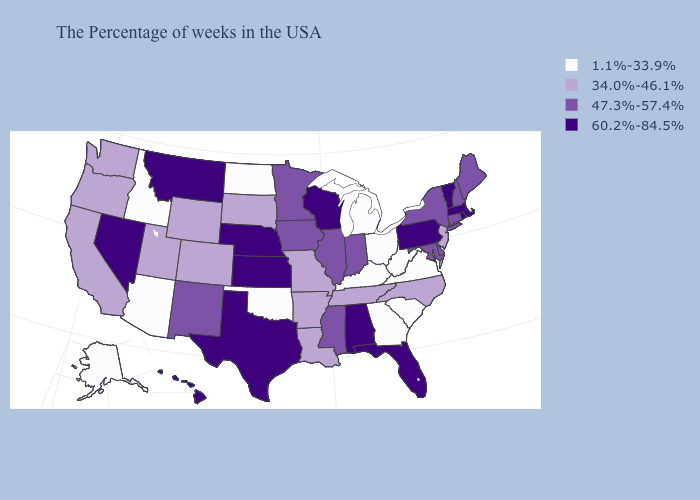How many symbols are there in the legend?
Short answer required. 4. Among the states that border Wyoming , which have the highest value?
Short answer required. Nebraska, Montana. Which states have the lowest value in the Northeast?
Give a very brief answer. New Jersey. What is the highest value in the USA?
Answer briefly. 60.2%-84.5%. What is the lowest value in the West?
Quick response, please. 1.1%-33.9%. What is the value of New Hampshire?
Keep it brief. 47.3%-57.4%. Does the first symbol in the legend represent the smallest category?
Quick response, please. Yes. Name the states that have a value in the range 34.0%-46.1%?
Be succinct. New Jersey, North Carolina, Tennessee, Louisiana, Missouri, Arkansas, South Dakota, Wyoming, Colorado, Utah, California, Washington, Oregon. Name the states that have a value in the range 1.1%-33.9%?
Be succinct. Virginia, South Carolina, West Virginia, Ohio, Georgia, Michigan, Kentucky, Oklahoma, North Dakota, Arizona, Idaho, Alaska. Among the states that border Delaware , which have the highest value?
Short answer required. Pennsylvania. Does Illinois have a lower value than Alabama?
Short answer required. Yes. What is the value of Texas?
Concise answer only. 60.2%-84.5%. Which states have the lowest value in the USA?
Quick response, please. Virginia, South Carolina, West Virginia, Ohio, Georgia, Michigan, Kentucky, Oklahoma, North Dakota, Arizona, Idaho, Alaska. Which states hav the highest value in the South?
Short answer required. Florida, Alabama, Texas. What is the highest value in states that border North Carolina?
Keep it brief. 34.0%-46.1%. 